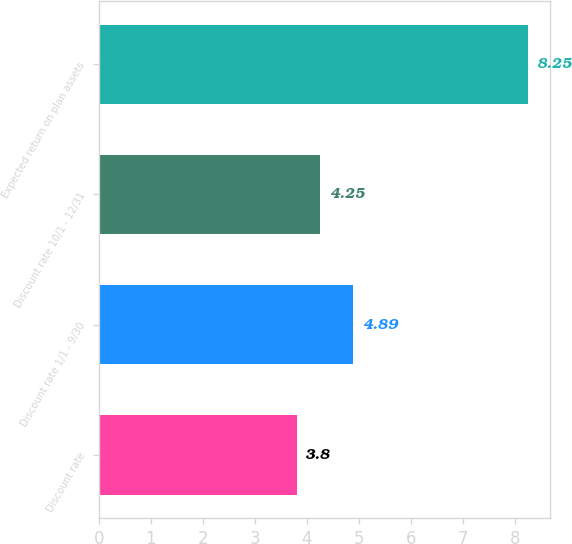Convert chart. <chart><loc_0><loc_0><loc_500><loc_500><bar_chart><fcel>Discount rate<fcel>Discount rate 1/1 - 9/30<fcel>Discount rate 10/1 - 12/31<fcel>Expected return on plan assets<nl><fcel>3.8<fcel>4.89<fcel>4.25<fcel>8.25<nl></chart> 